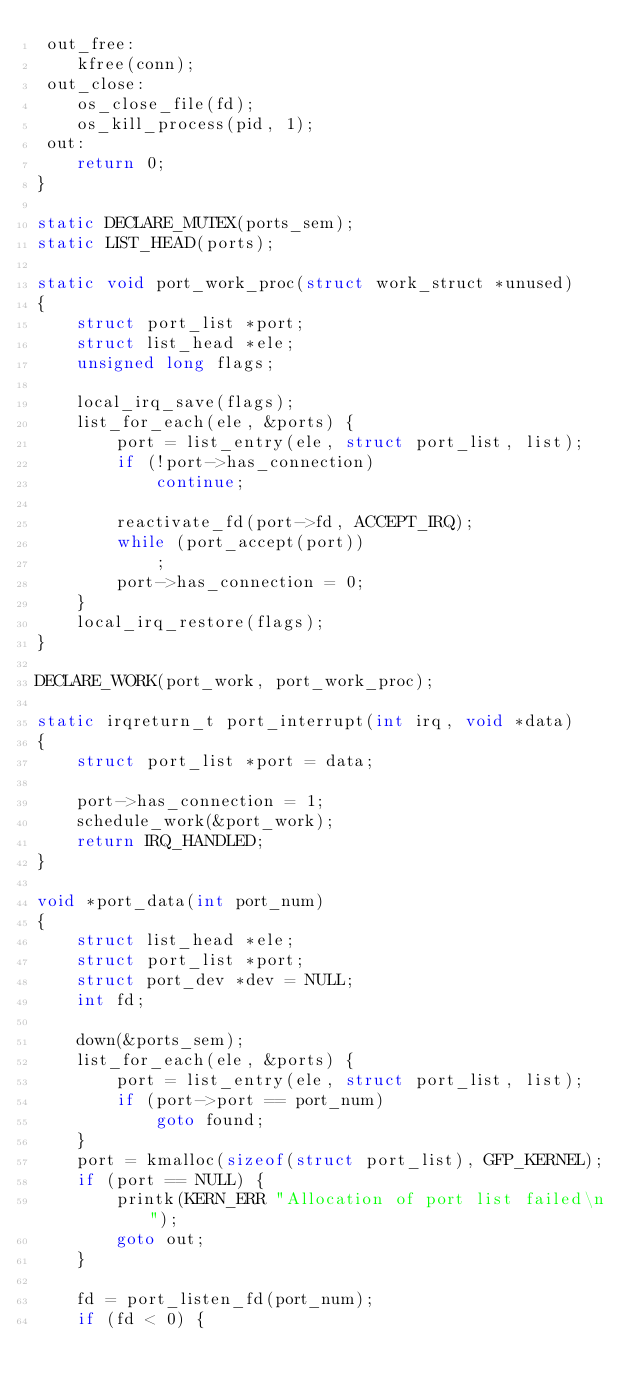<code> <loc_0><loc_0><loc_500><loc_500><_C_> out_free:
	kfree(conn);
 out_close:
	os_close_file(fd);
	os_kill_process(pid, 1);
 out:
	return 0;
}

static DECLARE_MUTEX(ports_sem);
static LIST_HEAD(ports);

static void port_work_proc(struct work_struct *unused)
{
	struct port_list *port;
	struct list_head *ele;
	unsigned long flags;

	local_irq_save(flags);
	list_for_each(ele, &ports) {
		port = list_entry(ele, struct port_list, list);
		if (!port->has_connection)
			continue;

		reactivate_fd(port->fd, ACCEPT_IRQ);
		while (port_accept(port))
			;
		port->has_connection = 0;
	}
	local_irq_restore(flags);
}

DECLARE_WORK(port_work, port_work_proc);

static irqreturn_t port_interrupt(int irq, void *data)
{
	struct port_list *port = data;

	port->has_connection = 1;
	schedule_work(&port_work);
	return IRQ_HANDLED;
}

void *port_data(int port_num)
{
	struct list_head *ele;
	struct port_list *port;
	struct port_dev *dev = NULL;
	int fd;

	down(&ports_sem);
	list_for_each(ele, &ports) {
		port = list_entry(ele, struct port_list, list);
		if (port->port == port_num)
			goto found;
	}
	port = kmalloc(sizeof(struct port_list), GFP_KERNEL);
	if (port == NULL) {
		printk(KERN_ERR "Allocation of port list failed\n");
		goto out;
	}

	fd = port_listen_fd(port_num);
	if (fd < 0) {</code> 